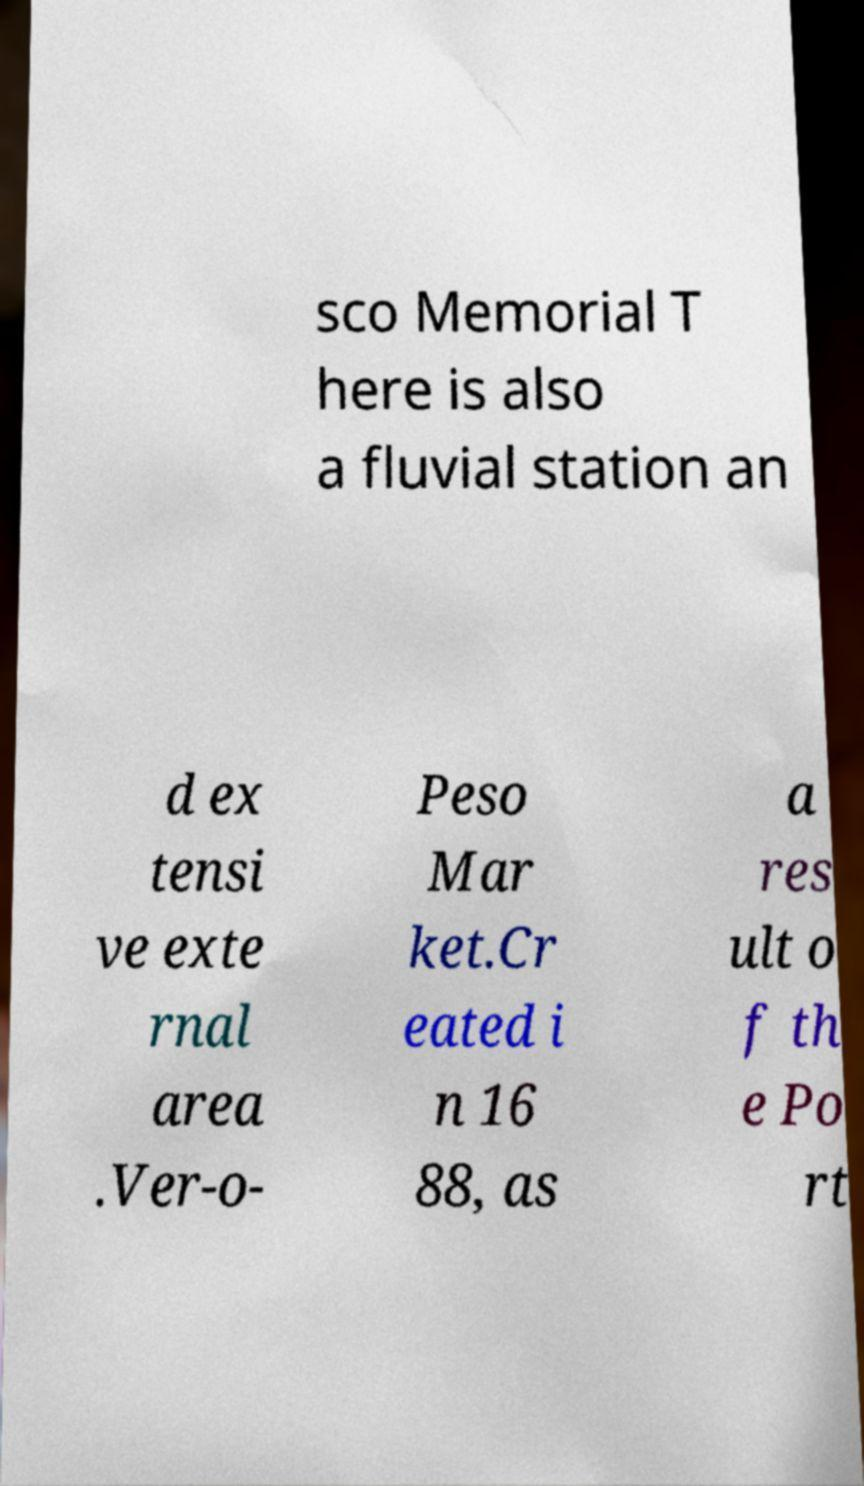Can you read and provide the text displayed in the image?This photo seems to have some interesting text. Can you extract and type it out for me? sco Memorial T here is also a fluvial station an d ex tensi ve exte rnal area .Ver-o- Peso Mar ket.Cr eated i n 16 88, as a res ult o f th e Po rt 